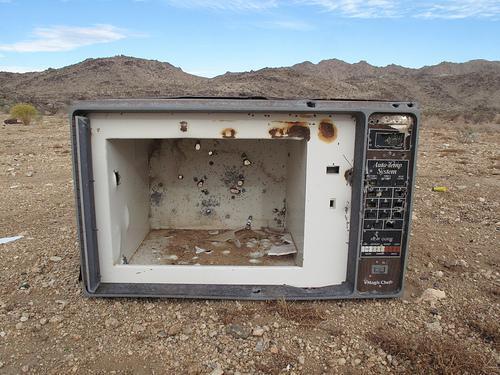How many microwaves are in the picture?
Give a very brief answer. 1. 